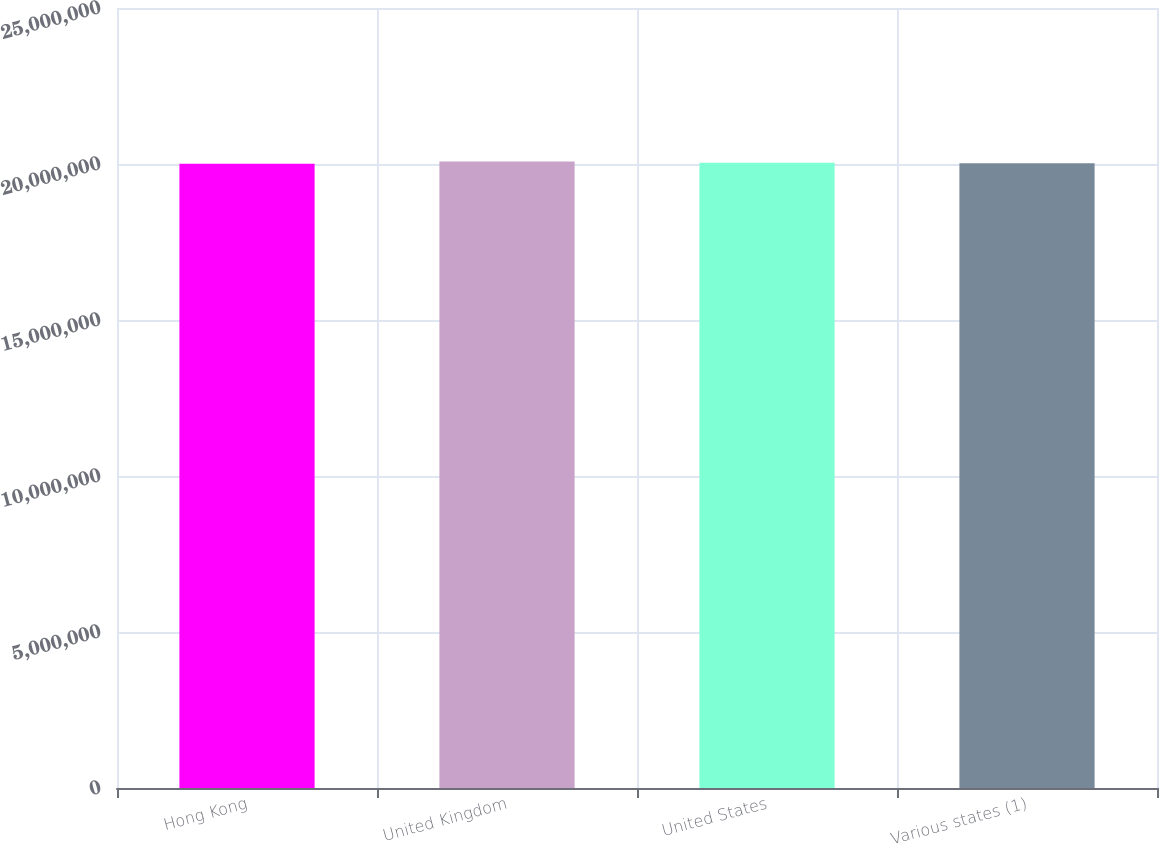<chart> <loc_0><loc_0><loc_500><loc_500><bar_chart><fcel>Hong Kong<fcel>United Kingdom<fcel>United States<fcel>Various states (1)<nl><fcel>2.0012e+07<fcel>2.0082e+07<fcel>2.0042e+07<fcel>2.0022e+07<nl></chart> 